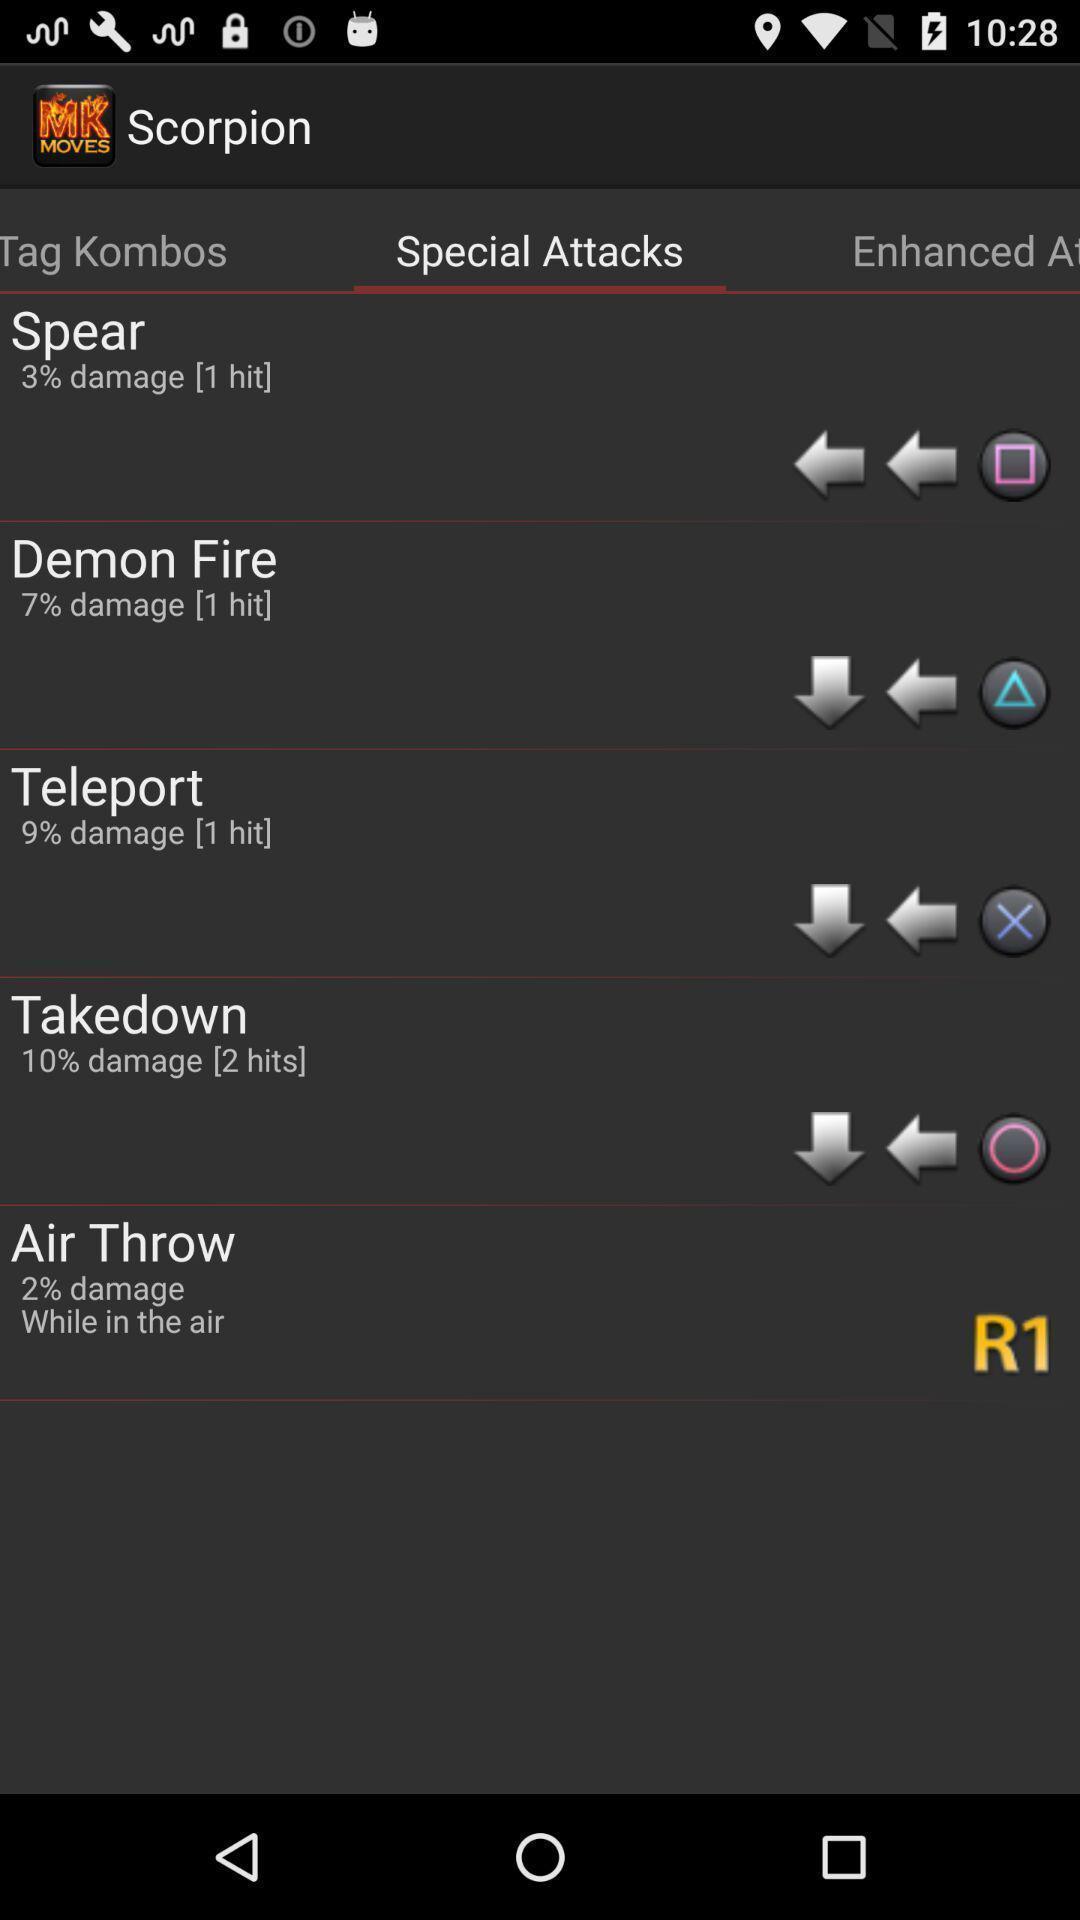Give me a narrative description of this picture. Page showing different options under special attacks. 